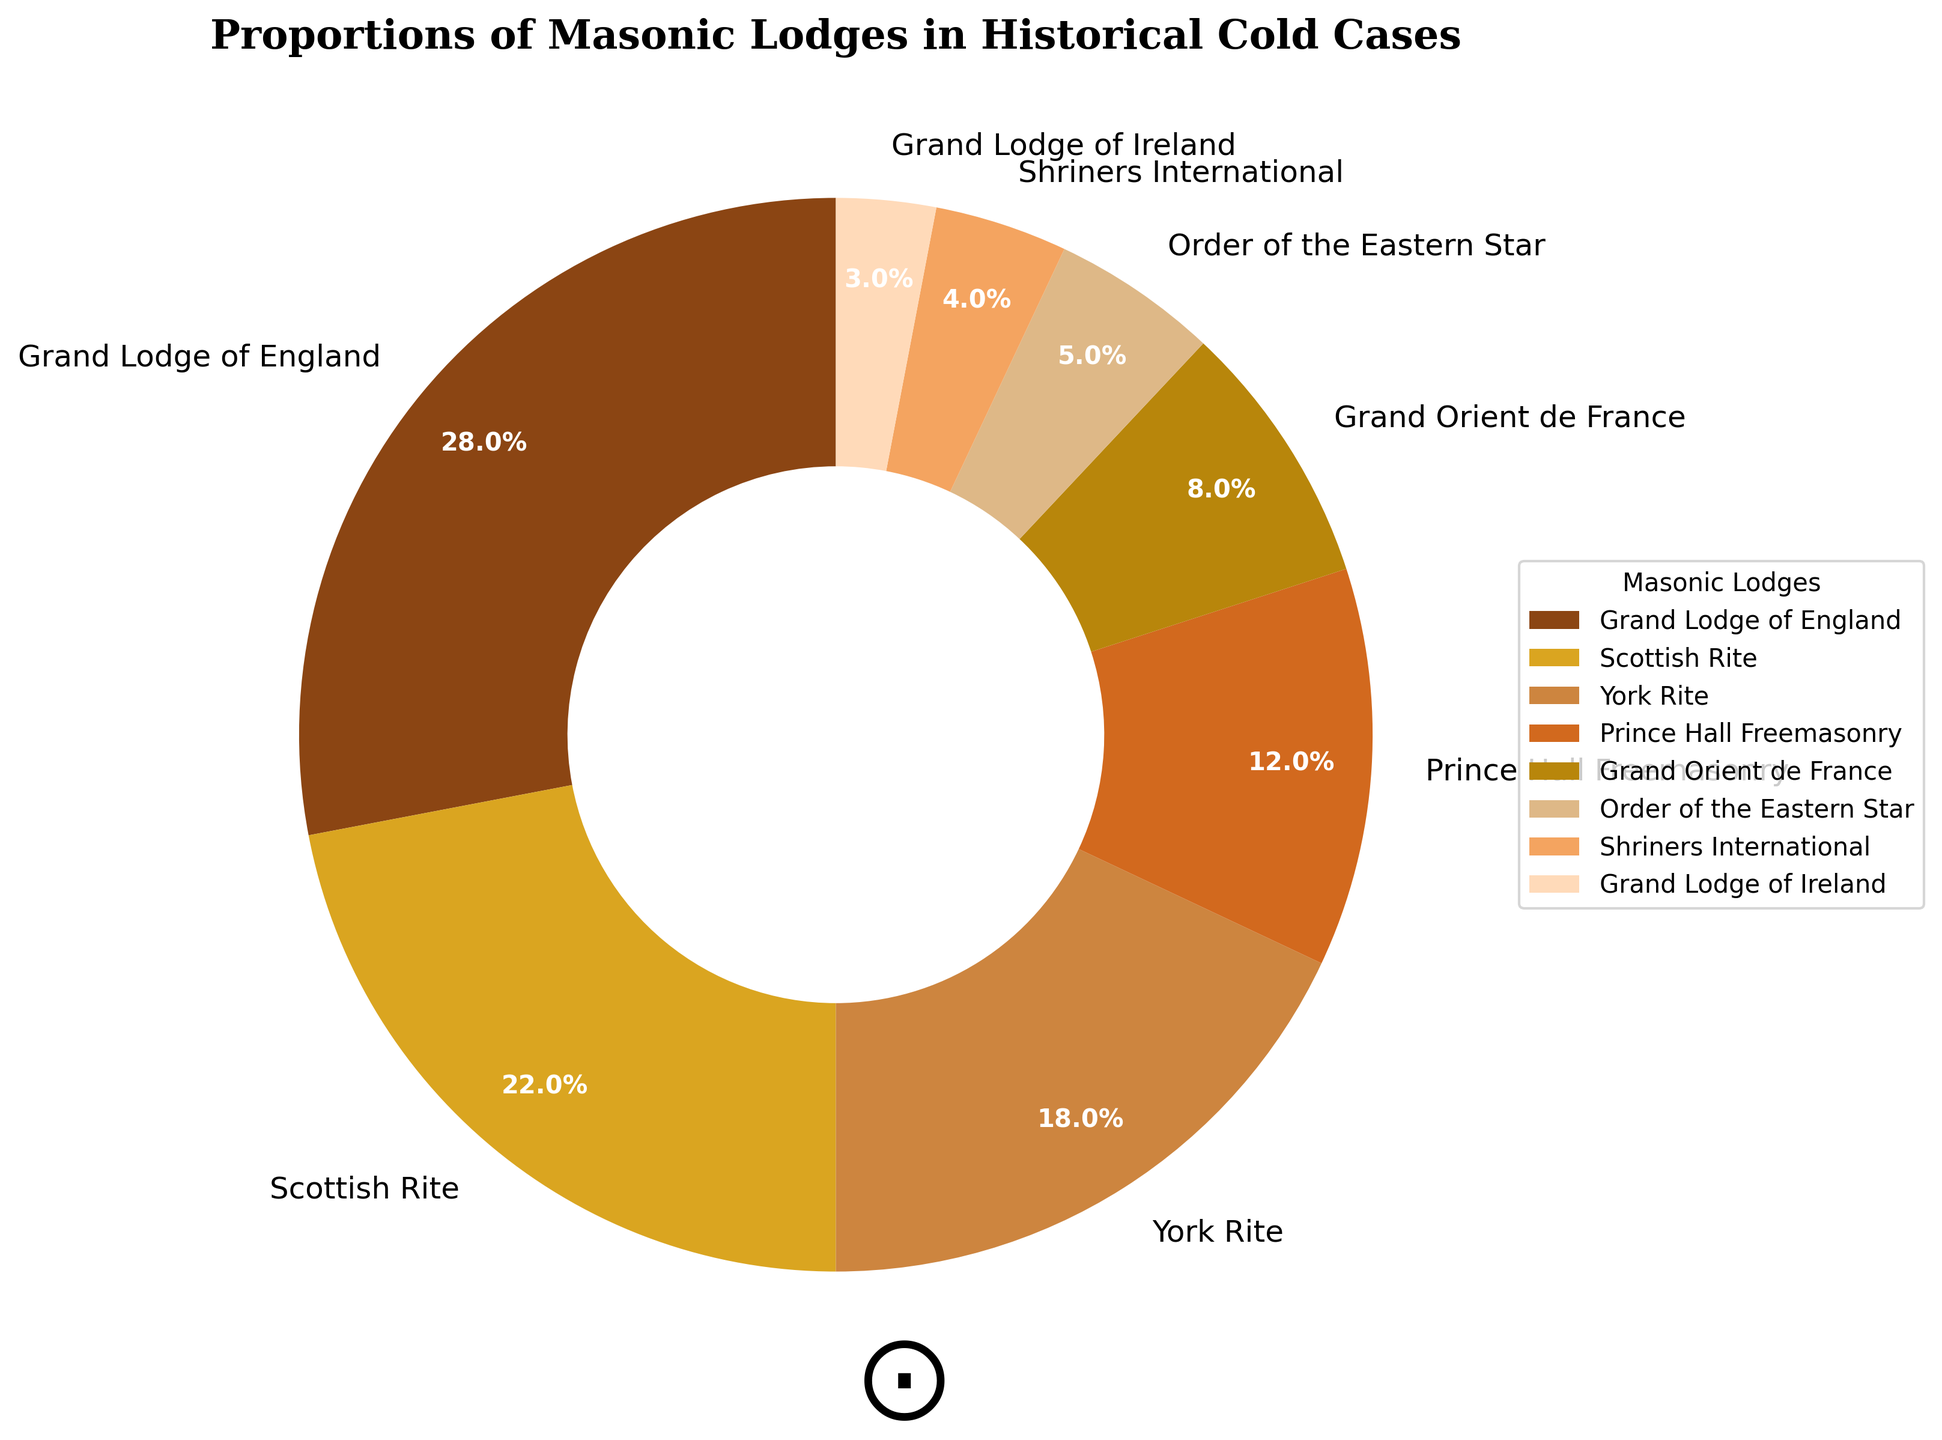What proportion of the Masonic lodges in historical cold cases is attributed to the Grand Lodge of England? The Grand Lodge of England has a segment labeled "28%" in the pie chart. This indicates that they are responsible for 28% of the Masonic lodges involved in historical cold cases.
Answer: 28% How do the proportions of the Scottish Rite and the York Rite compare? The Scottish Rite has 22% and the York Rite has 18%. By comparing these percentages, the Scottish Rite has a larger proportion.
Answer: Scottish Rite has a larger proportion What is the combined percentage of Prince Hall Freemasonry and Grand Orient de France? Prince Hall Freemasonry accounts for 12% and Grand Orient de France accounts for 8%. Summing these, 12% + 8% = 20%.
Answer: 20% Which lodge has the smallest involvement in historical cold cases? According to the pie chart, the Grand Lodge of Ireland has the smallest segment, which is indicated to be 3%.
Answer: Grand Lodge of Ireland How much larger is the proportion of the Grand Lodge of England compared to Shriners International? The Grand Lodge of England has a proportion of 28% while Shriners International has 4%. The difference is 28% - 4% = 24%.
Answer: 24% What's the difference in percentage between the largest and the smallest lodges? The largest lodge is the Grand Lodge of England at 28%, and the smallest is the Grand Lodge of Ireland at 3%. The difference is 28% - 3% = 25%.
Answer: 25% Rank the lodges from highest to lowest based on their involvement in historical cold cases. By examining the pie chart segments, the ranking from highest to lowest involvement is: Grand Lodge of England (28%), Scottish Rite (22%), York Rite (18%), Prince Hall Freemasonry (12%), Grand Orient de France (8%), Order of the Eastern Star (5%), Shriners International (4%), Grand Lodge of Ireland (3%).
Answer: Grand Lodge of England > Scottish Rite > York Rite > Prince Hall Freemasonry > Grand Orient de France > Order of the Eastern Star > Shriners International > Grand Lodge of Ireland What is the mean percentage involvement of the lodges? The involvement percentages are 28%, 22%, 18%, 12%, 8%, 5%, 4%, and 3%. Summing these gives 100%. Dividing by 8 (the total number of lodges) results in a mean of 100% / 8 = 12.5%.
Answer: 12.5% How does the percentage of the Order of the Eastern Star compare to that of the Grand Orient de France? The Order of the Eastern Star has a proportion of 5%, while the Grand Orient de France has 8%. Therefore, the Order of the Eastern Star is 3% less than the Grand Orient de France.
Answer: 3% less 